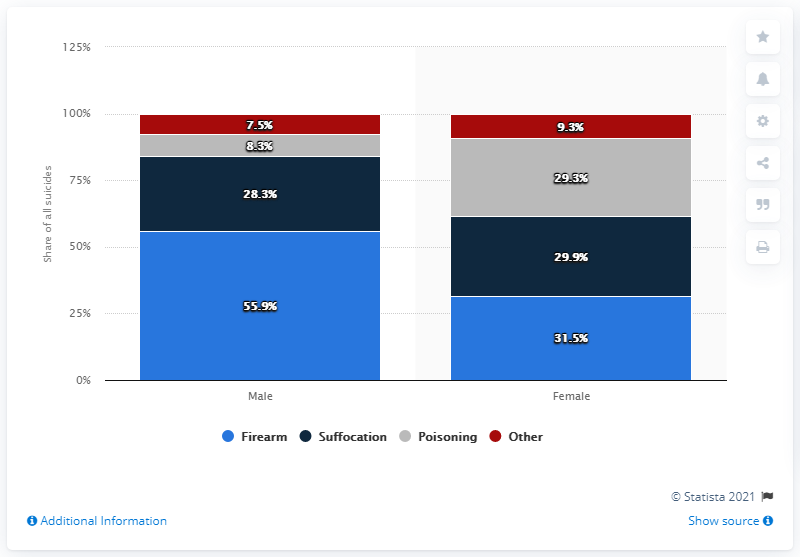Give some essential details in this illustration. The red bar is below 8%. Among the sexes, females had a smaller difference between death by firearm and suffocation compared to males. 